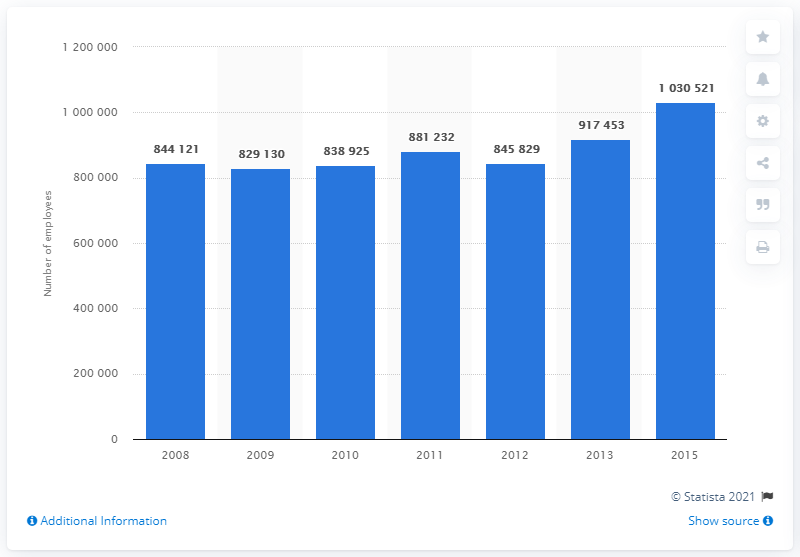List a handful of essential elements in this visual. In 2015, there were approximately 10,305,210 people employed in the ICT services industry. 